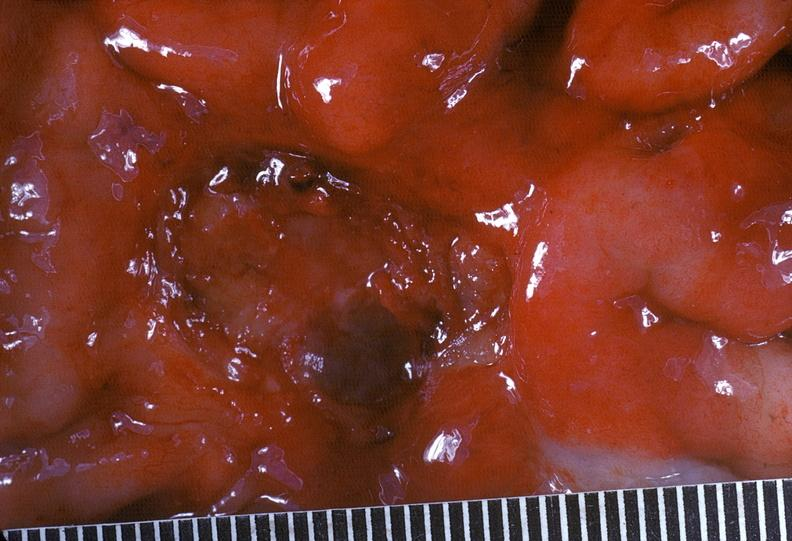does this image show stomach, peptic ulcer, chronic and peripheral carcinoma?
Answer the question using a single word or phrase. Yes 